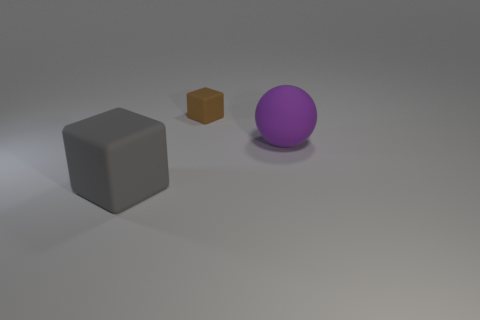There is a matte thing that is both in front of the tiny object and behind the large rubber cube; what is its size?
Your answer should be compact. Large. There is a large purple object; are there any rubber things in front of it?
Make the answer very short. Yes. What number of objects are big objects in front of the large purple rubber object or rubber balls?
Make the answer very short. 2. What number of big matte objects are behind the rubber block that is on the left side of the small brown matte cube?
Offer a terse response. 1. Is the number of gray rubber objects that are in front of the gray rubber object less than the number of small brown cubes left of the purple sphere?
Offer a terse response. Yes. The big object that is in front of the big thing to the right of the small brown object is what shape?
Your answer should be compact. Cube. How many other objects are there of the same material as the big purple thing?
Offer a terse response. 2. Is there anything else that is the same size as the brown block?
Give a very brief answer. No. Are there more tiny brown matte cubes than blue shiny cylinders?
Your response must be concise. Yes. What is the size of the object behind the large thing that is right of the matte block that is in front of the tiny matte object?
Your response must be concise. Small. 